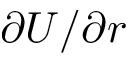<formula> <loc_0><loc_0><loc_500><loc_500>\partial U / \partial r</formula> 